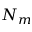<formula> <loc_0><loc_0><loc_500><loc_500>N _ { m }</formula> 